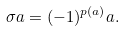Convert formula to latex. <formula><loc_0><loc_0><loc_500><loc_500>\sigma a = ( - 1 ) ^ { p ( a ) } a .</formula> 